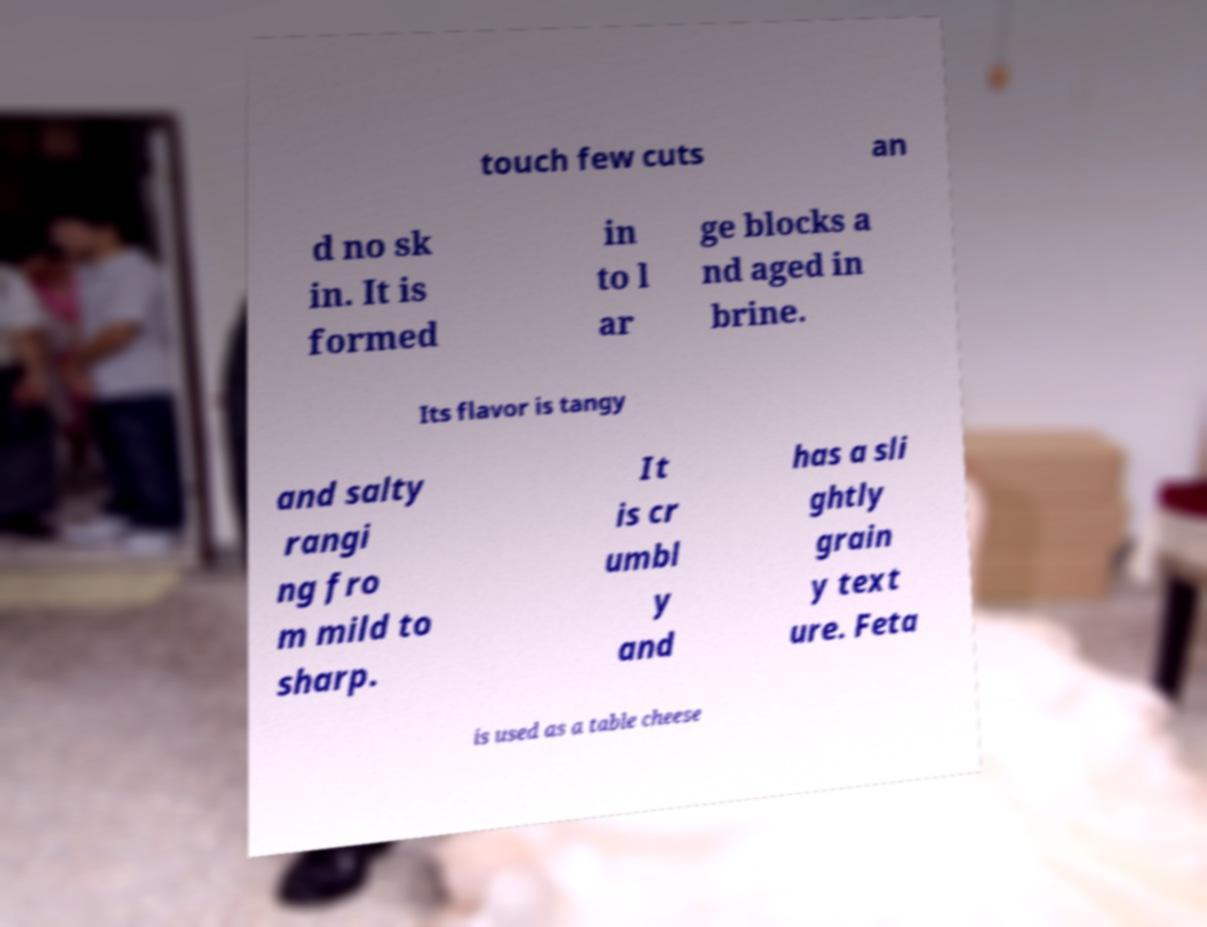Could you extract and type out the text from this image? touch few cuts an d no sk in. It is formed in to l ar ge blocks a nd aged in brine. Its flavor is tangy and salty rangi ng fro m mild to sharp. It is cr umbl y and has a sli ghtly grain y text ure. Feta is used as a table cheese 